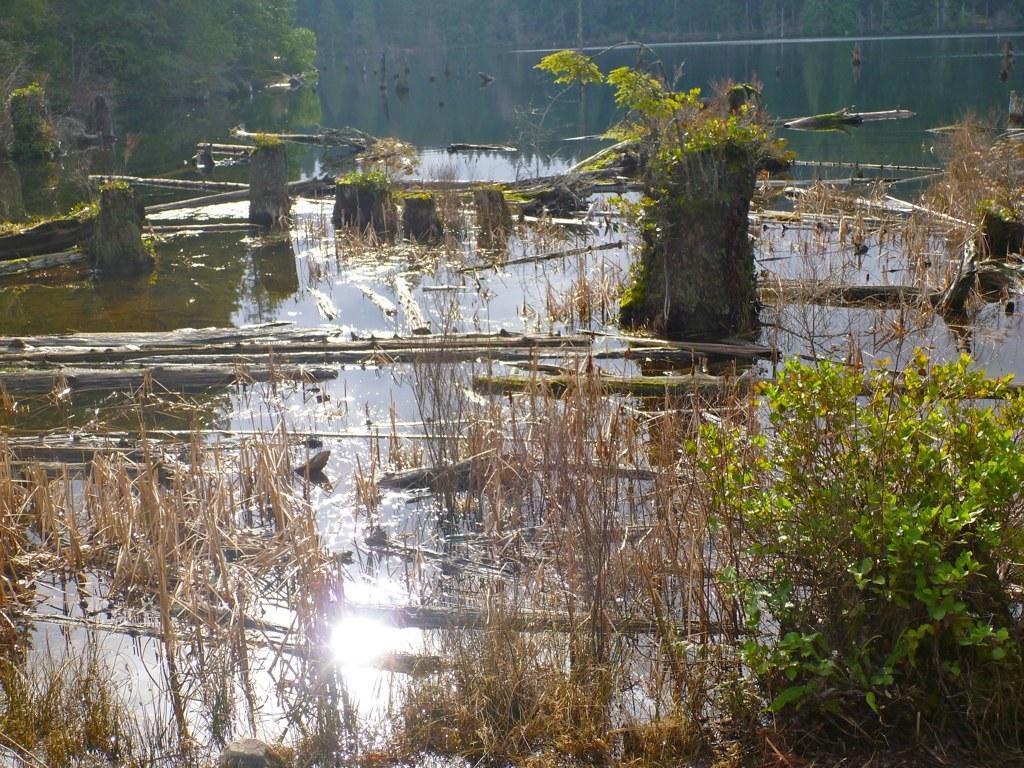Describe this image in one or two sentences. In the center of the image we can see water, plants, stick, grass are there. At the top left corner trees are present. 